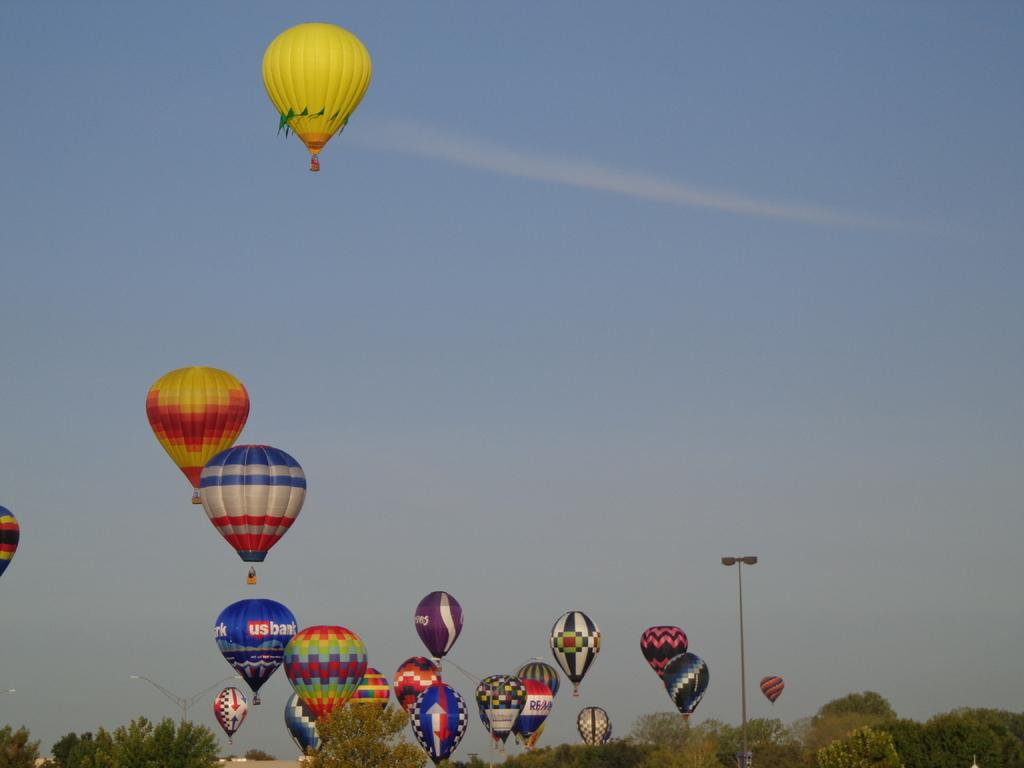What is happening in the sky in the image? There are air balloons flying in the sky in the image. What type of vegetation can be seen in the image? There are many trees visible in the image. What month is the parcel being delivered in the image? There is no parcel present in the image, so it is not possible to determine the month of delivery. 